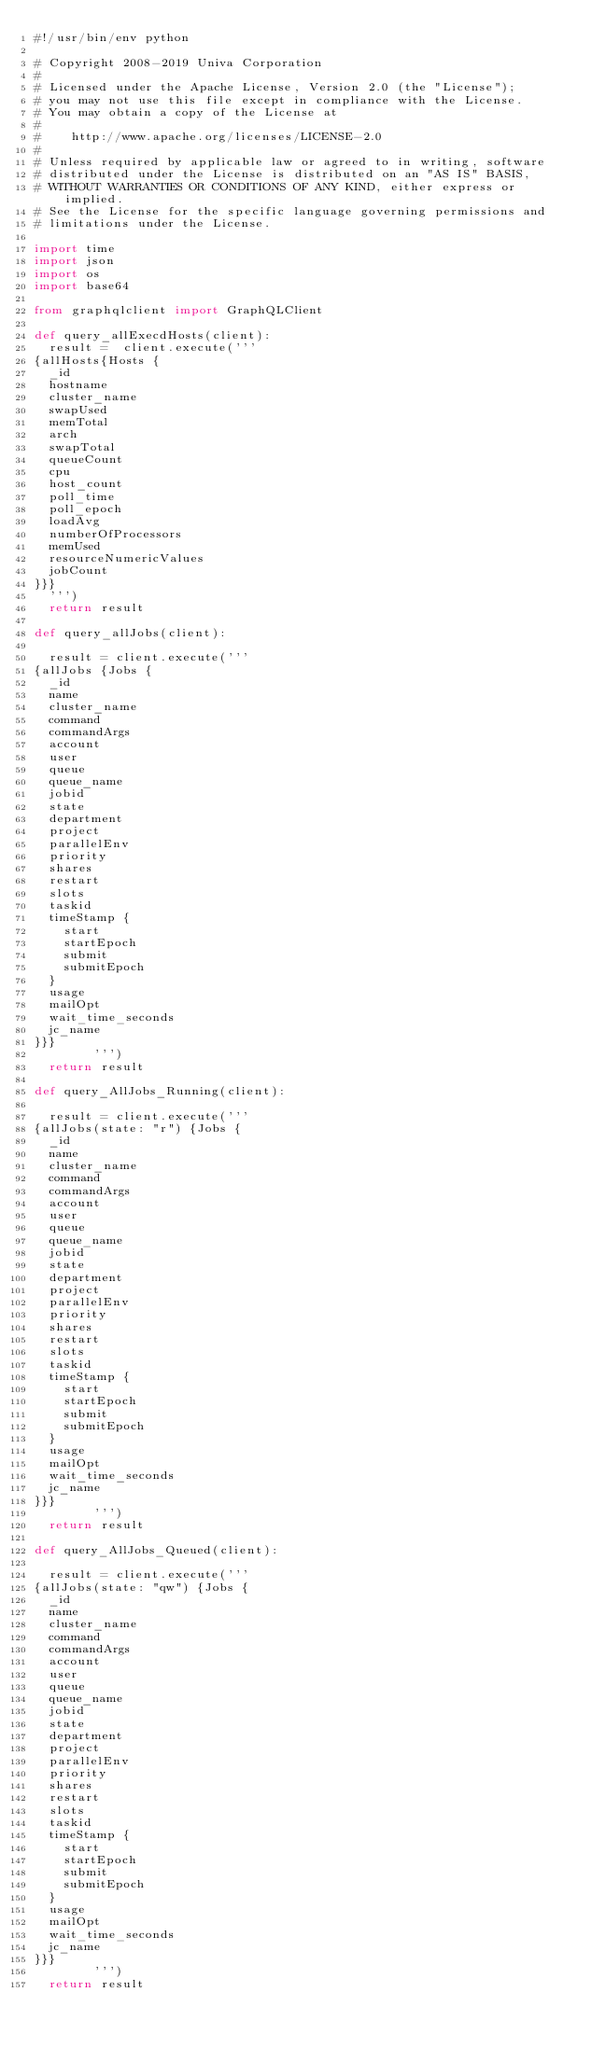<code> <loc_0><loc_0><loc_500><loc_500><_Python_>#!/usr/bin/env python

# Copyright 2008-2019 Univa Corporation
#
# Licensed under the Apache License, Version 2.0 (the "License");
# you may not use this file except in compliance with the License.
# You may obtain a copy of the License at
#
#    http://www.apache.org/licenses/LICENSE-2.0
#
# Unless required by applicable law or agreed to in writing, software
# distributed under the License is distributed on an "AS IS" BASIS,
# WITHOUT WARRANTIES OR CONDITIONS OF ANY KIND, either express or implied.
# See the License for the specific language governing permissions and
# limitations under the License.

import time
import json
import os
import base64

from graphqlclient import GraphQLClient

def query_allExecdHosts(client):
  result =  client.execute('''
{allHosts{Hosts {
  _id
  hostname
  cluster_name
  swapUsed
  memTotal
  arch
  swapTotal
  queueCount
  cpu
  host_count
  poll_time
  poll_epoch
  loadAvg
  numberOfProcessors
  memUsed
  resourceNumericValues
  jobCount
}}}
  ''')
  return result

def query_allJobs(client):

  result = client.execute('''
{allJobs {Jobs {
  _id
  name
  cluster_name
  command
  commandArgs
  account
  user
  queue
  queue_name
  jobid
  state
  department
  project
  parallelEnv
  priority
  shares
  restart
  slots
  taskid
  timeStamp {
    start
    startEpoch
    submit
    submitEpoch
  }
  usage
  mailOpt
  wait_time_seconds
  jc_name
}}}
        ''')
  return result

def query_AllJobs_Running(client):

  result = client.execute('''
{allJobs(state: "r") {Jobs {
  _id
  name
  cluster_name
  command
  commandArgs
  account
  user
  queue
  queue_name
  jobid
  state
  department
  project
  parallelEnv
  priority
  shares
  restart
  slots
  taskid
  timeStamp {
    start
    startEpoch
    submit
    submitEpoch
  }
  usage
  mailOpt
  wait_time_seconds
  jc_name
}}}
        ''')
  return result

def query_AllJobs_Queued(client):

  result = client.execute('''
{allJobs(state: "qw") {Jobs {
  _id
  name
  cluster_name
  command
  commandArgs
  account
  user
  queue
  queue_name
  jobid
  state
  department
  project
  parallelEnv
  priority
  shares
  restart
  slots
  taskid
  timeStamp {
    start
    startEpoch
    submit
    submitEpoch
  }
  usage
  mailOpt
  wait_time_seconds
  jc_name
}}}
        ''')
  return result
</code> 